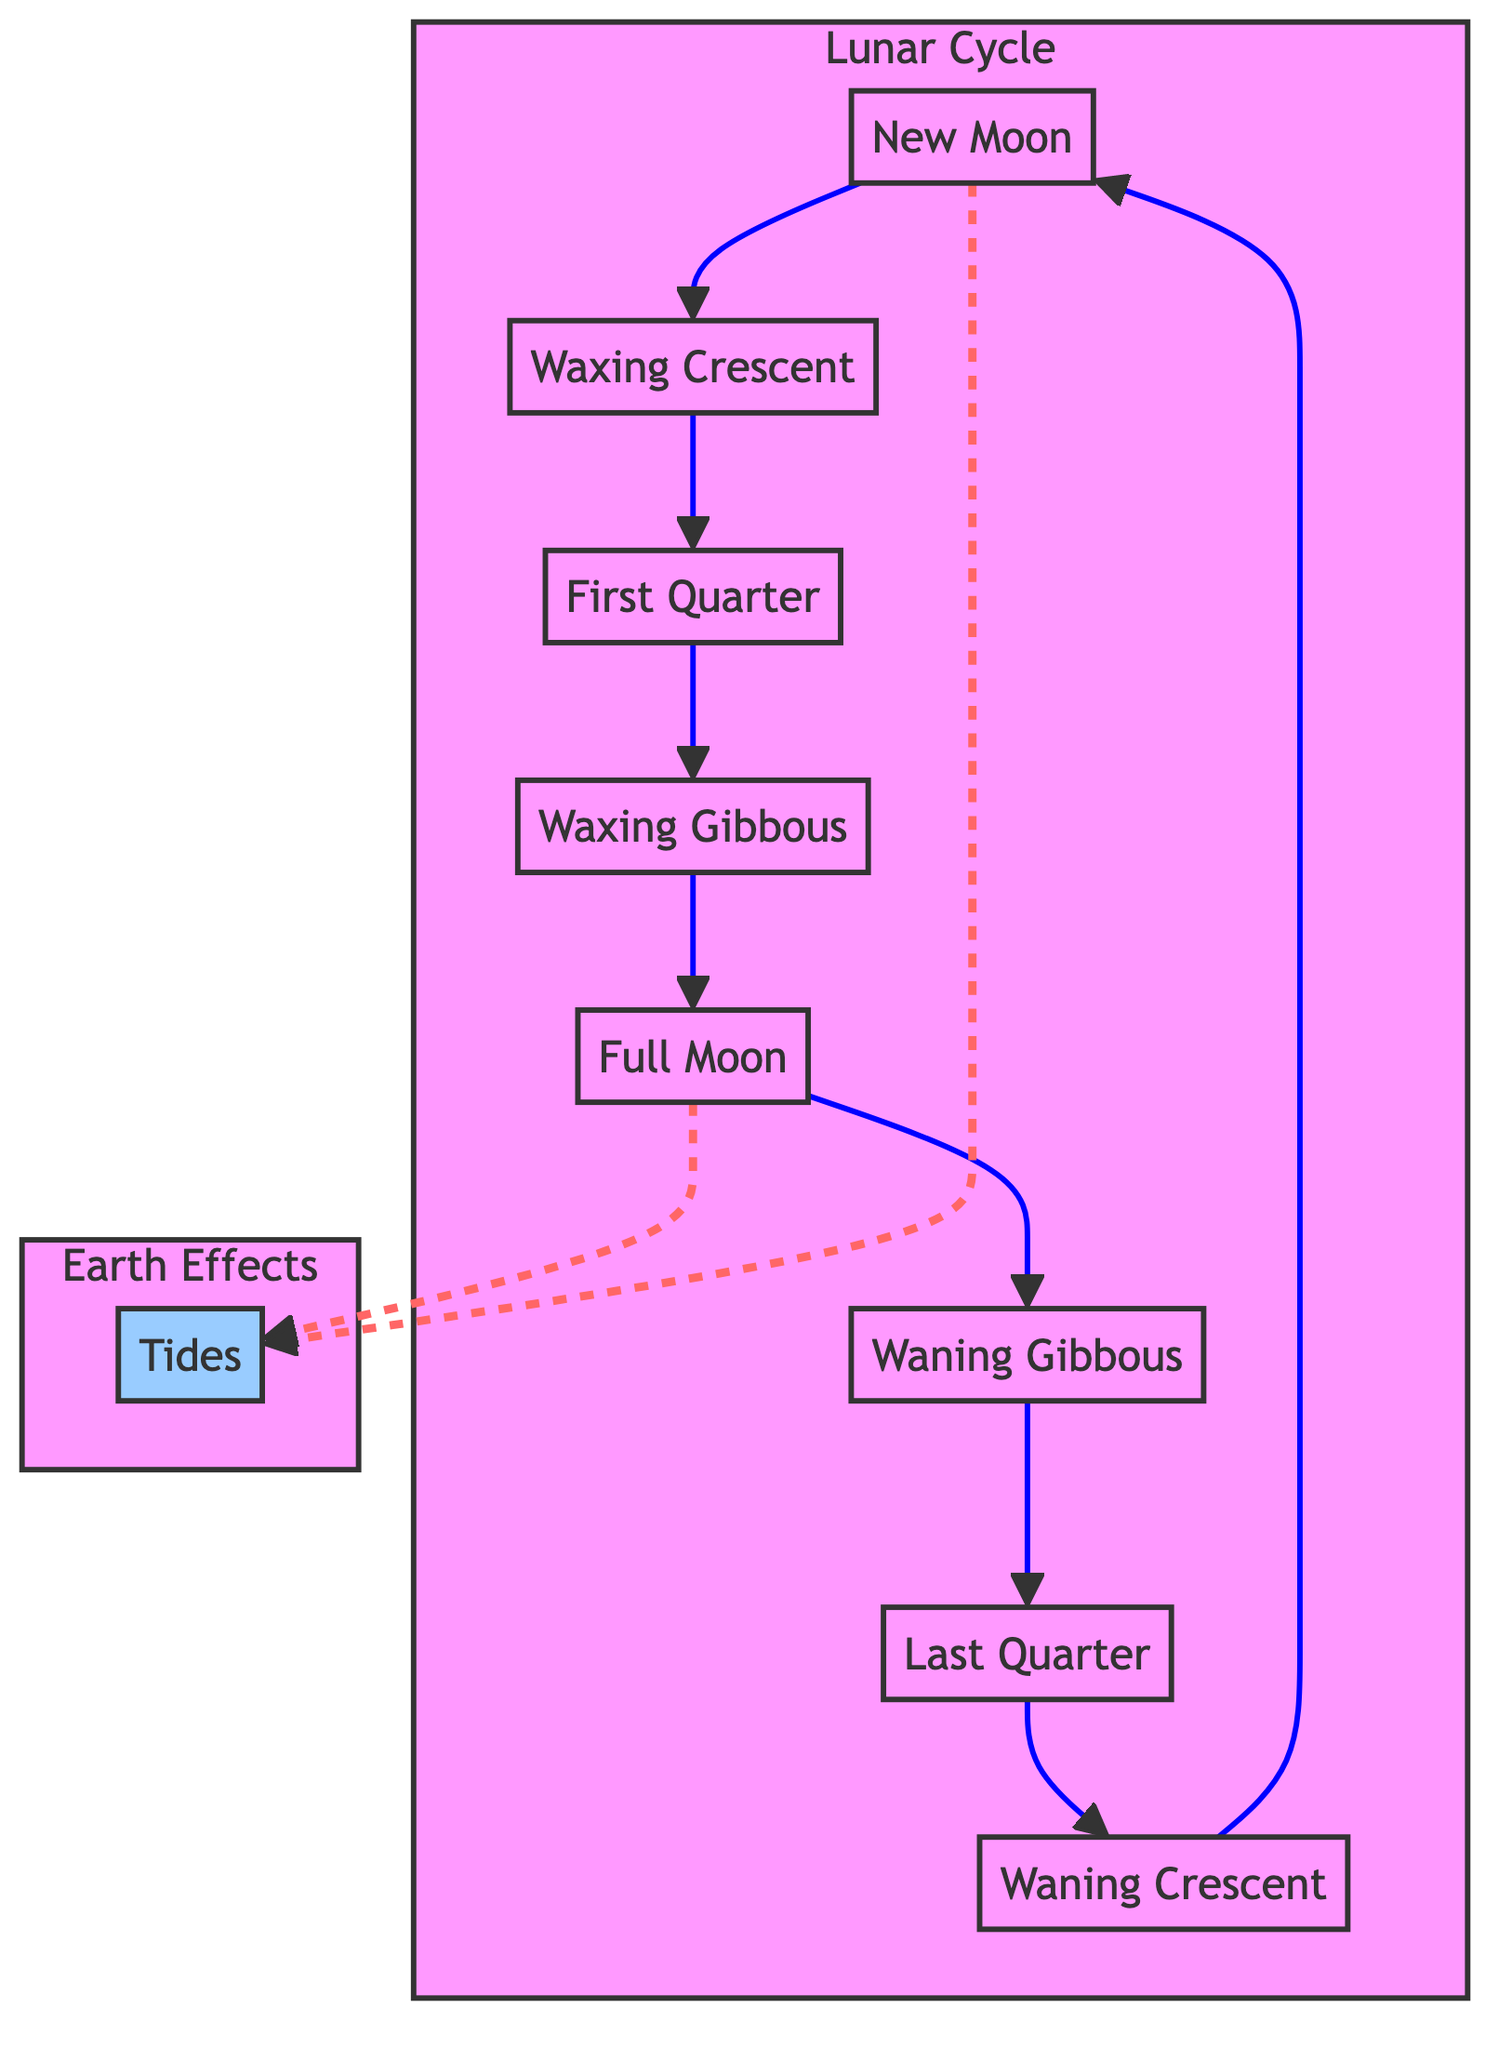What is the first phase of the lunar cycle? According to the diagram, the first phase of the lunar cycle is labeled as "New Moon."
Answer: New Moon How many phases are there in the lunar cycle shown in the diagram? The diagram illustrates eight phases of the moon, which are New Moon, Waxing Crescent, First Quarter, Waxing Gibbous, Full Moon, Waning Gibbous, Last Quarter, and Waning Crescent.
Answer: Eight Which moon phase is associated with the highest tides? The diagram indicates that the "Full Moon" phase is associated with the highest tides, as it is connected to the tidal effect in the diagram.
Answer: Full Moon During which phase does the moon appear to be half illuminated? The "First Quarter" and "Last Quarter" phases represent when the moon appears to be half illuminated from Earth, and both phases are listed in the diagram.
Answer: First Quarter, Last Quarter What happens to tides during the New Moon phase? The diagram shows a dashed line from "New Moon" to "Tides," indicating that New Moon also affects tides, resulting in higher tides.
Answer: Tides If the moon is in the Waning Gibbous phase, what was the previous phase? The diagram shows that "Waning Gibbous" follows "Full Moon," so the previous phase would be "Full Moon."
Answer: Full Moon How do the waxing phases relate to the tidal effects shown in the diagram? The waxing phases, "Waxing Crescent," "First Quarter," and "Waxing Gibbous," lead up to the "Full Moon," which is connected to tidal effects, indicating they also contribute to increasing tidal levels.
Answer: Increasing tidal levels What is the last phase of the lunar cycle before it returns to the New Moon? The last phase before returning to the New Moon in the lunar cycle as per the diagram is "Waning Crescent."
Answer: Waning Crescent What is the effect of the Full Moon on tides according to the diagram? The dashed line shows that during the Full Moon phase, tides are affected significantly, typically resulting in more pronounced high tides.
Answer: High tides 